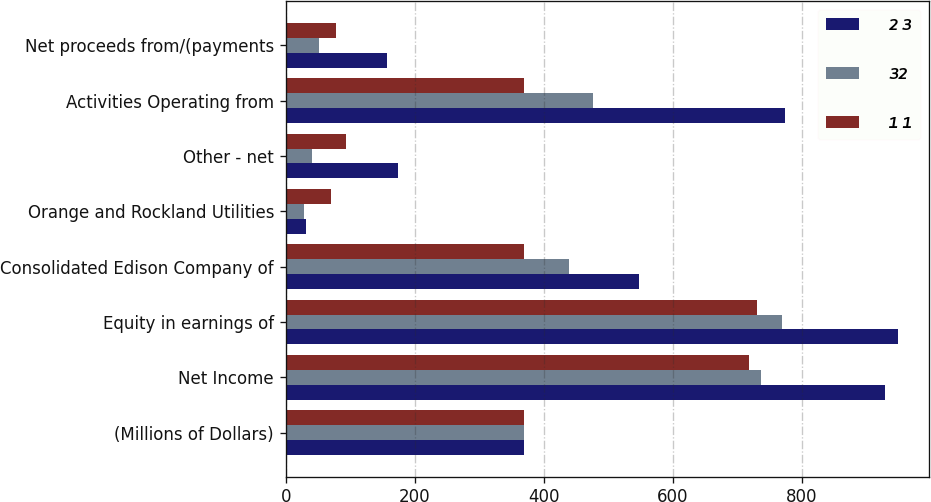Convert chart to OTSL. <chart><loc_0><loc_0><loc_500><loc_500><stacked_bar_chart><ecel><fcel>(Millions of Dollars)<fcel>Net Income<fcel>Equity in earnings of<fcel>Consolidated Edison Company of<fcel>Orange and Rockland Utilities<fcel>Other - net<fcel>Activities Operating from<fcel>Net proceeds from/(payments<nl><fcel>2 3<fcel>369<fcel>929<fcel>950<fcel>548<fcel>31<fcel>174<fcel>775<fcel>157<nl><fcel>32<fcel>369<fcel>737<fcel>769<fcel>440<fcel>28<fcel>41<fcel>477<fcel>51<nl><fcel>1 1<fcel>369<fcel>719<fcel>731<fcel>369<fcel>71<fcel>94<fcel>369<fcel>78<nl></chart> 